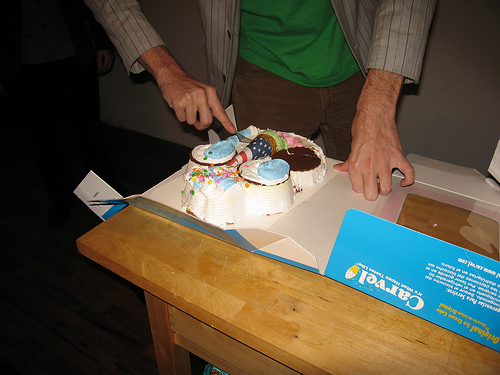How many people are in the picture? There is 1 person visible in the picture, currently in the act of cutting a round cake that has colorful decorations on top. 